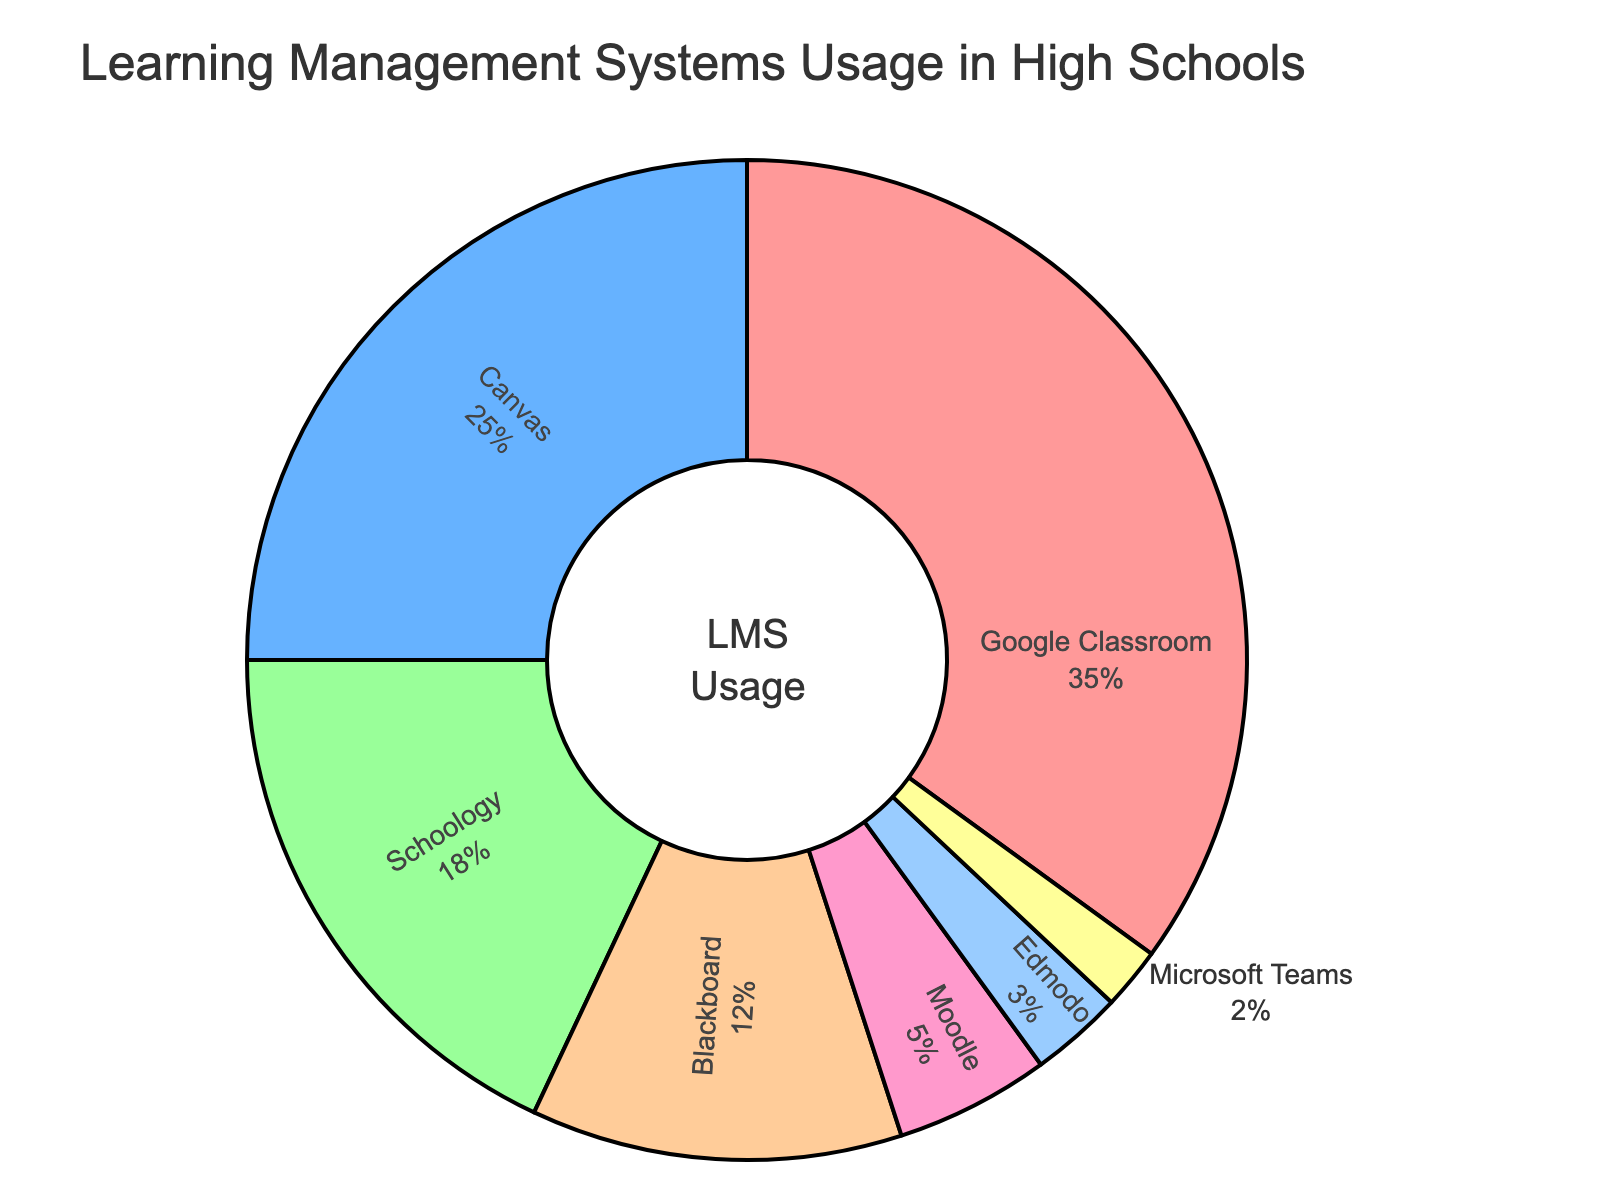What's the most used LMS in high schools? The figure shows that the largest portion of the pie chart is labeled “Google Classroom” with 35%.
Answer: Google Classroom Which LMS has the smallest usage percentage? The smallest segment of the pie chart is labeled “Microsoft Teams” with 2%.
Answer: Microsoft Teams What percentage of high school students use either Canvas or Schoology? The percentages for Canvas and Schoology are 25% and 18% respectively. Adding them together gives 25% + 18% = 43%.
Answer: 43% How much more popular is Google Classroom compared to Blackboard? Google Classroom has 35% usage, while Blackboard has 12%. Subtracting these gives 35% - 12% = 23%.
Answer: 23% What is the combined usage percentage of Moodle and Edmodo? Moodle’s percentage is 5% and Edmodo’s is 3%. Summing them gives 5% + 3% = 8%.
Answer: 8% Which LMS has a higher usage: Schoology or Moodle? The figure shows that Schoology has 18% usage and Moodle has 5%. 18% is higher than 5%.
Answer: Schoology How does the usage of Microsoft Teams compare to Edmodo? Microsoft Teams has a usage percentage of 2%, while Edmodo has 3%. Microsoft Teams has 1% less usage than Edmodo.
Answer: Edmodo What percentage of students use neither Google Classroom nor Canvas? Google Classroom accounts for 35% and Canvas for 25%. Subtracting their combined sum from 100% gives 100% - 35% - 25% = 40%.
Answer: 40% Which LMS has the second highest usage after Google Classroom? The figure shows that Canvas is the second largest segment with 25% usage after Google Classroom, which has 35%.
Answer: Canvas Combine the percentages of the two least popular LMSes. What do you get? The figure shows that Microsoft Teams has 2% and Edmodo has 3%. Adding them together yields 2% + 3% = 5%.
Answer: 5% 